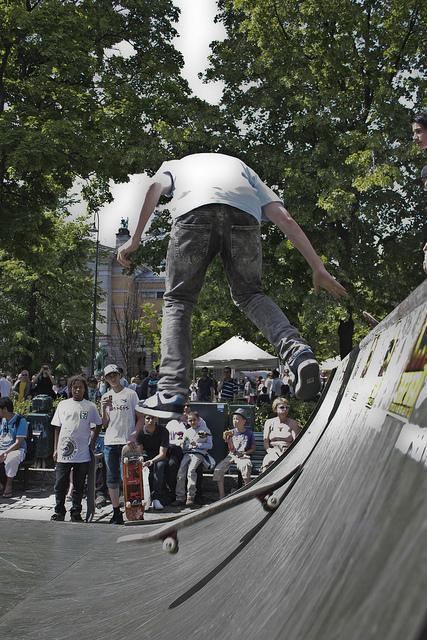Why is he in the air above the skateboard?
Make your selection and explain in format: 'Answer: answer
Rationale: rationale.'
Options: Bouncing, showing off, confused, falling. Answer: showing off.
Rationale: He is doing a trick in front of people who are watching. 